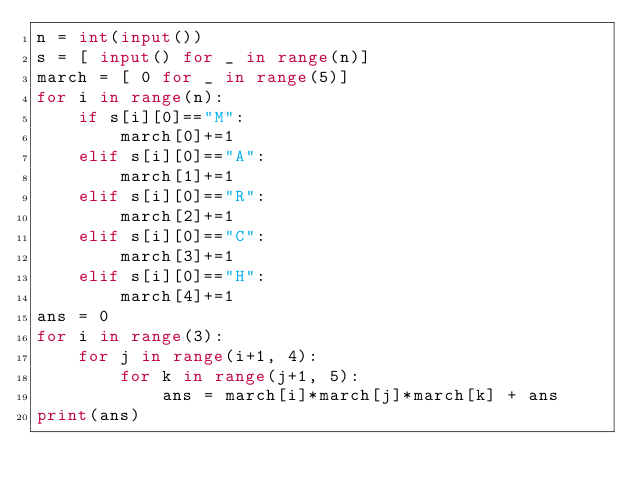<code> <loc_0><loc_0><loc_500><loc_500><_Python_>n = int(input())
s = [ input() for _ in range(n)]
march = [ 0 for _ in range(5)]
for i in range(n):
    if s[i][0]=="M":
        march[0]+=1
    elif s[i][0]=="A":
        march[1]+=1
    elif s[i][0]=="R":
        march[2]+=1
    elif s[i][0]=="C":
        march[3]+=1
    elif s[i][0]=="H":
        march[4]+=1
ans = 0
for i in range(3):
    for j in range(i+1, 4):
        for k in range(j+1, 5):
            ans = march[i]*march[j]*march[k] + ans
print(ans)
</code> 